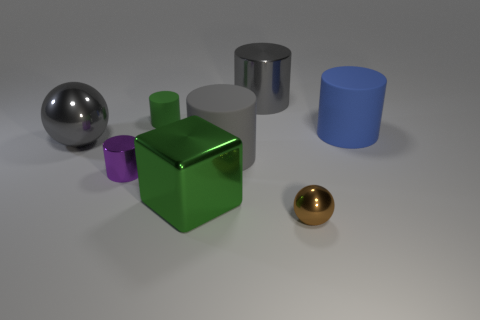Subtract all green cylinders. How many cylinders are left? 4 Subtract all small purple metal cylinders. How many cylinders are left? 4 Subtract 1 cylinders. How many cylinders are left? 4 Subtract all red cylinders. Subtract all cyan balls. How many cylinders are left? 5 Add 1 tiny metallic objects. How many objects exist? 9 Subtract all blocks. How many objects are left? 7 Subtract all brown objects. Subtract all big blue rubber things. How many objects are left? 6 Add 4 large cylinders. How many large cylinders are left? 7 Add 3 big metal blocks. How many big metal blocks exist? 4 Subtract 0 yellow blocks. How many objects are left? 8 